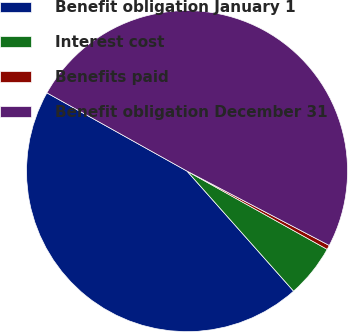Convert chart. <chart><loc_0><loc_0><loc_500><loc_500><pie_chart><fcel>Benefit obligation January 1<fcel>Interest cost<fcel>Benefits paid<fcel>Benefit obligation December 31<nl><fcel>44.66%<fcel>5.34%<fcel>0.44%<fcel>49.56%<nl></chart> 